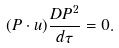<formula> <loc_0><loc_0><loc_500><loc_500>( P \cdot u ) \frac { D P ^ { 2 } } { d \tau } = 0 .</formula> 